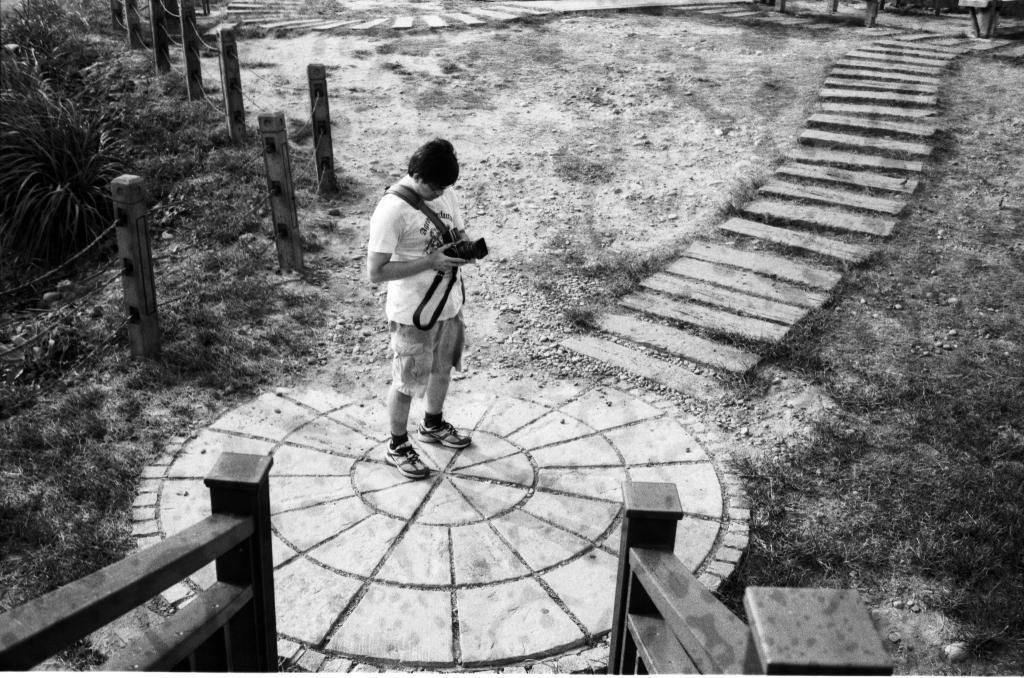Can you describe this image briefly? It looks like a black and white picture. We can see a man is standing on the path and holding a camera. Behind the man there are poles with ropes and plants. 